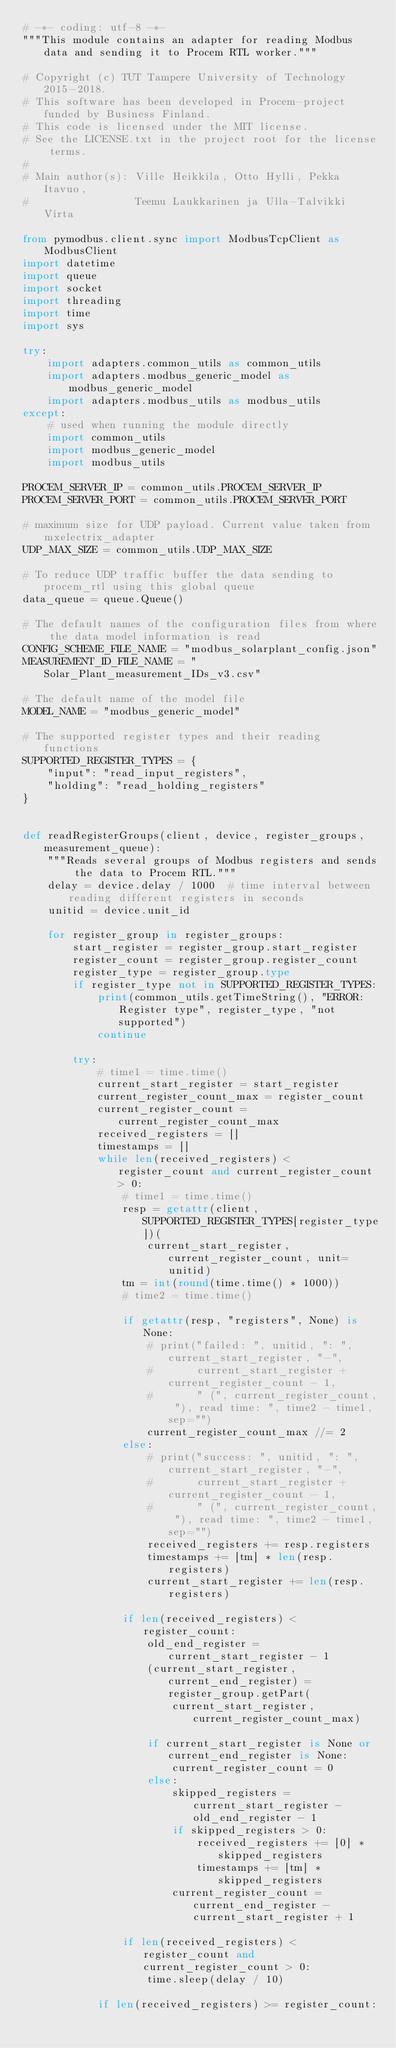<code> <loc_0><loc_0><loc_500><loc_500><_Python_># -*- coding: utf-8 -*-
"""This module contains an adapter for reading Modbus data and sending it to Procem RTL worker."""

# Copyright (c) TUT Tampere University of Technology 2015-2018.
# This software has been developed in Procem-project funded by Business Finland.
# This code is licensed under the MIT license.
# See the LICENSE.txt in the project root for the license terms.
#
# Main author(s): Ville Heikkila, Otto Hylli, Pekka Itavuo,
#                 Teemu Laukkarinen ja Ulla-Talvikki Virta

from pymodbus.client.sync import ModbusTcpClient as ModbusClient
import datetime
import queue
import socket
import threading
import time
import sys

try:
    import adapters.common_utils as common_utils
    import adapters.modbus_generic_model as modbus_generic_model
    import adapters.modbus_utils as modbus_utils
except:
    # used when running the module directly
    import common_utils
    import modbus_generic_model
    import modbus_utils

PROCEM_SERVER_IP = common_utils.PROCEM_SERVER_IP
PROCEM_SERVER_PORT = common_utils.PROCEM_SERVER_PORT

# maximum size for UDP payload. Current value taken from mxelectrix_adapter
UDP_MAX_SIZE = common_utils.UDP_MAX_SIZE

# To reduce UDP traffic buffer the data sending to procem_rtl using this global queue
data_queue = queue.Queue()

# The default names of the configuration files from where the data model information is read
CONFIG_SCHEME_FILE_NAME = "modbus_solarplant_config.json"
MEASUREMENT_ID_FILE_NAME = "Solar_Plant_measurement_IDs_v3.csv"

# The default name of the model file
MODEL_NAME = "modbus_generic_model"

# The supported register types and their reading functions
SUPPORTED_REGISTER_TYPES = {
    "input": "read_input_registers",
    "holding": "read_holding_registers"
}


def readRegisterGroups(client, device, register_groups, measurement_queue):
    """Reads several groups of Modbus registers and sends the data to Procem RTL."""
    delay = device.delay / 1000  # time interval between reading different registers in seconds
    unitid = device.unit_id

    for register_group in register_groups:
        start_register = register_group.start_register
        register_count = register_group.register_count
        register_type = register_group.type
        if register_type not in SUPPORTED_REGISTER_TYPES:
            print(common_utils.getTimeString(), "ERROR: Register type", register_type, "not supported")
            continue

        try:
            # time1 = time.time()
            current_start_register = start_register
            current_register_count_max = register_count
            current_register_count = current_register_count_max
            received_registers = []
            timestamps = []
            while len(received_registers) < register_count and current_register_count > 0:
                # time1 = time.time()
                resp = getattr(client, SUPPORTED_REGISTER_TYPES[register_type])(
                    current_start_register, current_register_count, unit=unitid)
                tm = int(round(time.time() * 1000))
                # time2 = time.time()

                if getattr(resp, "registers", None) is None:
                    # print("failed: ", unitid, ": ", current_start_register, "-",
                    #       current_start_register + current_register_count - 1,
                    #       " (", current_register_count, "), read time: ", time2 - time1, sep="")
                    current_register_count_max //= 2
                else:
                    # print("success: ", unitid, ": ", current_start_register, "-",
                    #       current_start_register + current_register_count - 1,
                    #       " (", current_register_count, "), read time: ", time2 - time1, sep="")
                    received_registers += resp.registers
                    timestamps += [tm] * len(resp.registers)
                    current_start_register += len(resp.registers)

                if len(received_registers) < register_count:
                    old_end_register = current_start_register - 1
                    (current_start_register, current_end_register) = register_group.getPart(
                        current_start_register, current_register_count_max)

                    if current_start_register is None or current_end_register is None:
                        current_register_count = 0
                    else:
                        skipped_registers = current_start_register - old_end_register - 1
                        if skipped_registers > 0:
                            received_registers += [0] * skipped_registers
                            timestamps += [tm] * skipped_registers
                        current_register_count = current_end_register - current_start_register + 1

                if len(received_registers) < register_count and current_register_count > 0:
                    time.sleep(delay / 10)

            if len(received_registers) >= register_count:</code> 